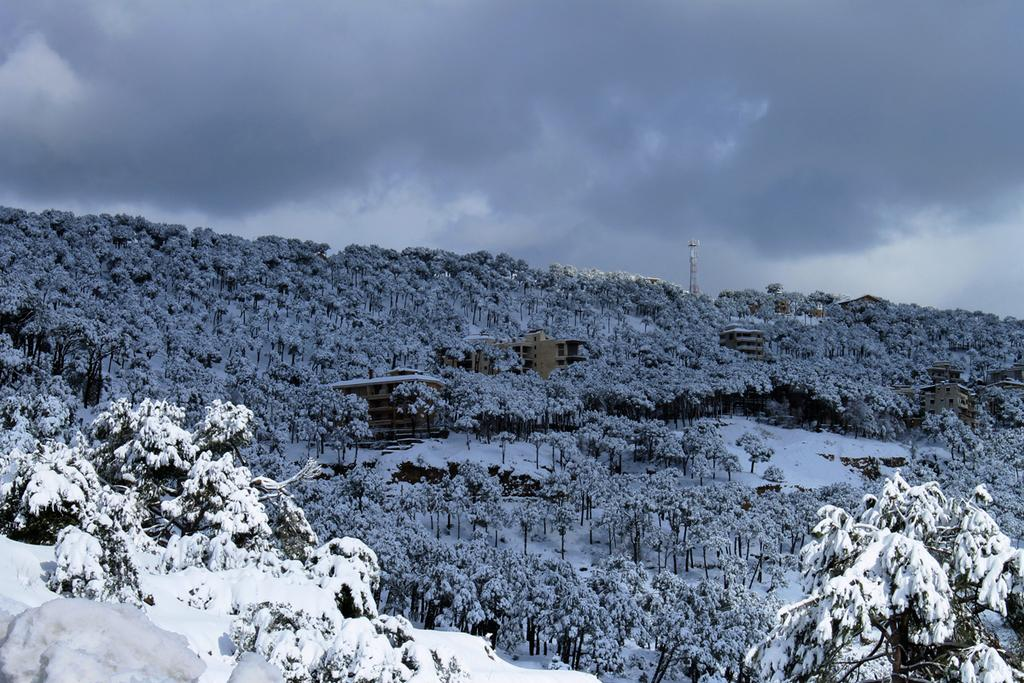What type of natural elements can be seen in the image? There are trees in the image. What type of man-made structures are present in the image? There are buildings and a tower in the image. What is the weather like in the image? There is snow visible in the image, indicating a cold or wintery environment. What is visible in the background of the image? The sky is visible in the background of the image, with clouds present. Where is the picture of the basin located in the image? There is no picture of a basin present in the image. What type of hair care tool is visible in the image? There is no hair care tool, such as a comb, present in the image. 